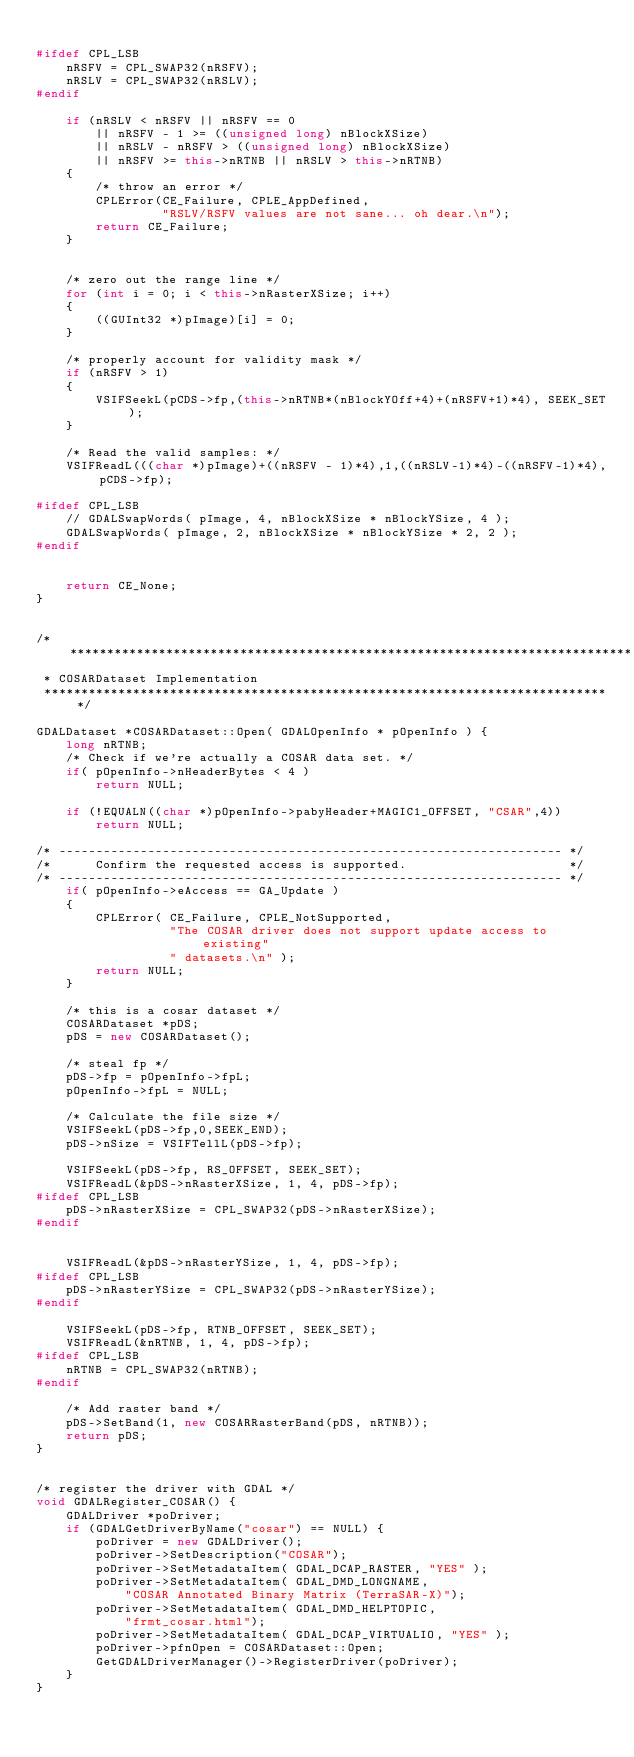Convert code to text. <code><loc_0><loc_0><loc_500><loc_500><_C++_>
#ifdef CPL_LSB
    nRSFV = CPL_SWAP32(nRSFV);
    nRSLV = CPL_SWAP32(nRSLV);
#endif

    if (nRSLV < nRSFV || nRSFV == 0
        || nRSFV - 1 >= ((unsigned long) nBlockXSize)
        || nRSLV - nRSFV > ((unsigned long) nBlockXSize)
        || nRSFV >= this->nRTNB || nRSLV > this->nRTNB)
    {
        /* throw an error */
        CPLError(CE_Failure, CPLE_AppDefined,
                 "RSLV/RSFV values are not sane... oh dear.\n");	
        return CE_Failure;
    }
	
	
    /* zero out the range line */
    for (int i = 0; i < this->nRasterXSize; i++)
    {
        ((GUInt32 *)pImage)[i] = 0;
    }

    /* properly account for validity mask */ 
    if (nRSFV > 1)
    {
        VSIFSeekL(pCDS->fp,(this->nRTNB*(nBlockYOff+4)+(nRSFV+1)*4), SEEK_SET);
    }

    /* Read the valid samples: */
    VSIFReadL(((char *)pImage)+((nRSFV - 1)*4),1,((nRSLV-1)*4)-((nRSFV-1)*4),pCDS->fp);

#ifdef CPL_LSB
    // GDALSwapWords( pImage, 4, nBlockXSize * nBlockYSize, 4 );
    GDALSwapWords( pImage, 2, nBlockXSize * nBlockYSize * 2, 2 );
#endif


    return CE_None;
}


/*****************************************************************************
 * COSARDataset Implementation
 *****************************************************************************/

GDALDataset *COSARDataset::Open( GDALOpenInfo * pOpenInfo ) {
    long nRTNB;
    /* Check if we're actually a COSAR data set. */
    if( pOpenInfo->nHeaderBytes < 4 )
        return NULL;

    if (!EQUALN((char *)pOpenInfo->pabyHeader+MAGIC1_OFFSET, "CSAR",4)) 
        return NULL;

/* -------------------------------------------------------------------- */
/*      Confirm the requested access is supported.                      */
/* -------------------------------------------------------------------- */
    if( pOpenInfo->eAccess == GA_Update )
    {
        CPLError( CE_Failure, CPLE_NotSupported, 
                  "The COSAR driver does not support update access to existing"
                  " datasets.\n" );
        return NULL;
    }
    
    /* this is a cosar dataset */
    COSARDataset *pDS;
    pDS = new COSARDataset();
	
    /* steal fp */
    pDS->fp = pOpenInfo->fpL;
    pOpenInfo->fpL = NULL;

    /* Calculate the file size */
    VSIFSeekL(pDS->fp,0,SEEK_END);
    pDS->nSize = VSIFTellL(pDS->fp);

    VSIFSeekL(pDS->fp, RS_OFFSET, SEEK_SET);
    VSIFReadL(&pDS->nRasterXSize, 1, 4, pDS->fp);  
#ifdef CPL_LSB
    pDS->nRasterXSize = CPL_SWAP32(pDS->nRasterXSize);
#endif
	
	
    VSIFReadL(&pDS->nRasterYSize, 1, 4, pDS->fp);
#ifdef CPL_LSB
    pDS->nRasterYSize = CPL_SWAP32(pDS->nRasterYSize);
#endif

    VSIFSeekL(pDS->fp, RTNB_OFFSET, SEEK_SET);
    VSIFReadL(&nRTNB, 1, 4, pDS->fp);
#ifdef CPL_LSB
    nRTNB = CPL_SWAP32(nRTNB);
#endif

    /* Add raster band */
    pDS->SetBand(1, new COSARRasterBand(pDS, nRTNB));
    return pDS;	
}


/* register the driver with GDAL */
void GDALRegister_COSAR() {
	GDALDriver *poDriver;
	if (GDALGetDriverByName("cosar") == NULL) {
		poDriver = new GDALDriver();
		poDriver->SetDescription("COSAR");
        poDriver->SetMetadataItem( GDAL_DCAP_RASTER, "YES" );
		poDriver->SetMetadataItem( GDAL_DMD_LONGNAME,
			"COSAR Annotated Binary Matrix (TerraSAR-X)");
		poDriver->SetMetadataItem( GDAL_DMD_HELPTOPIC,
			"frmt_cosar.html");
        poDriver->SetMetadataItem( GDAL_DCAP_VIRTUALIO, "YES" );
		poDriver->pfnOpen = COSARDataset::Open;
		GetGDALDriverManager()->RegisterDriver(poDriver);
	}
}
</code> 